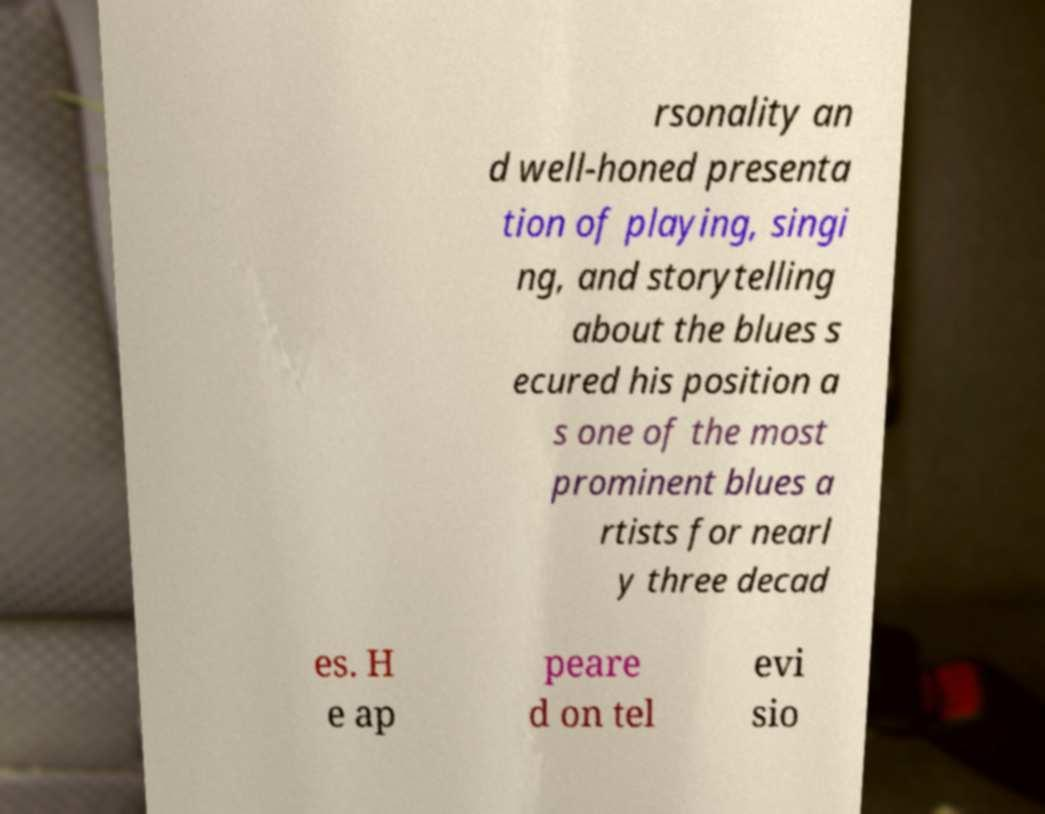I need the written content from this picture converted into text. Can you do that? rsonality an d well-honed presenta tion of playing, singi ng, and storytelling about the blues s ecured his position a s one of the most prominent blues a rtists for nearl y three decad es. H e ap peare d on tel evi sio 